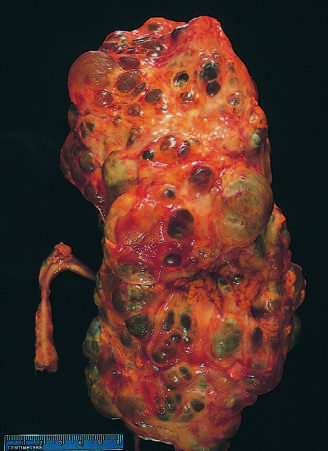s libman-sacks endocarditis markedly enlarged?
Answer the question using a single word or phrase. No 